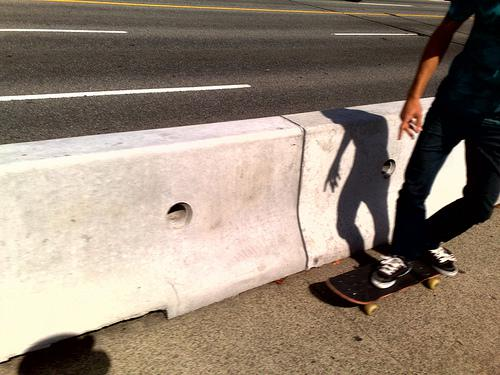Question: where is he going?
Choices:
A. Up the road.
B. Down the street.
C. Down to the store.
D. To his house.
Answer with the letter. Answer: B Question: what is next to him?
Choices:
A. The house.
B. The traffic light.
C. The highway.
D. The school.
Answer with the letter. Answer: C Question: what color are his pants?
Choices:
A. Blue.
B. Green.
C. Red.
D. Black.
Answer with the letter. Answer: D Question: who is on the street?
Choices:
A. The bicyclist.
B. The runner.
C. The mailman.
D. The skateboarder.
Answer with the letter. Answer: D Question: when will he skate?
Choices:
A. Later in the day.
B. In a few hours.
C. Now.
D. Tomorrow.
Answer with the letter. Answer: C Question: what is the boy doing?
Choices:
A. Skating.
B. Running.
C. Playing soccer.
D. Skiing.
Answer with the letter. Answer: A 